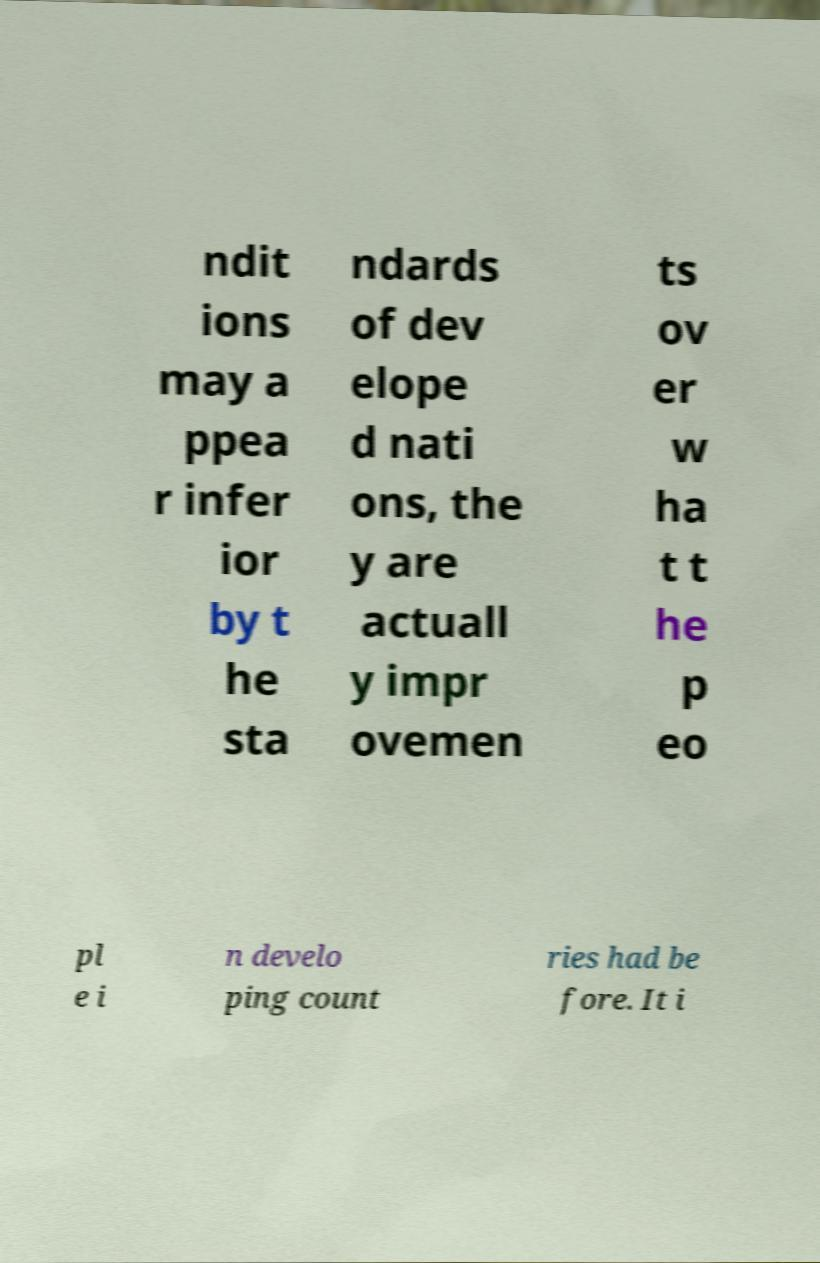Can you accurately transcribe the text from the provided image for me? ndit ions may a ppea r infer ior by t he sta ndards of dev elope d nati ons, the y are actuall y impr ovemen ts ov er w ha t t he p eo pl e i n develo ping count ries had be fore. It i 